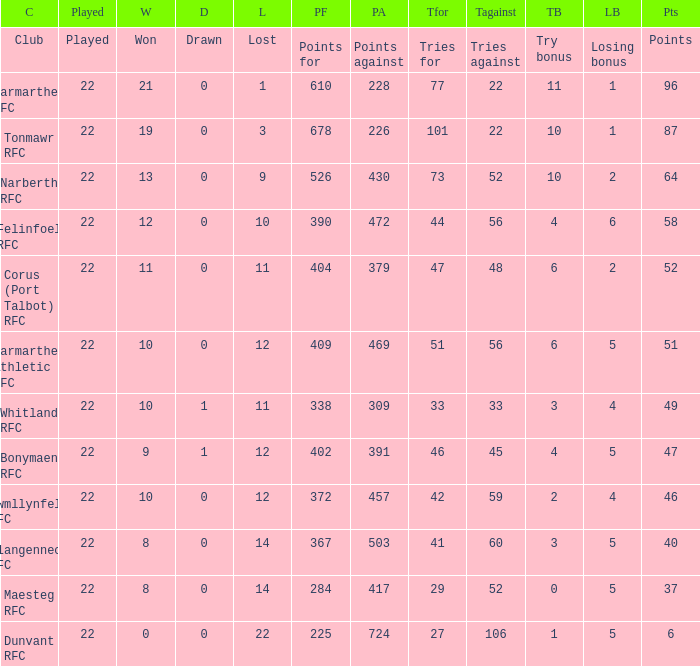Name the points against for 51 points 469.0. 